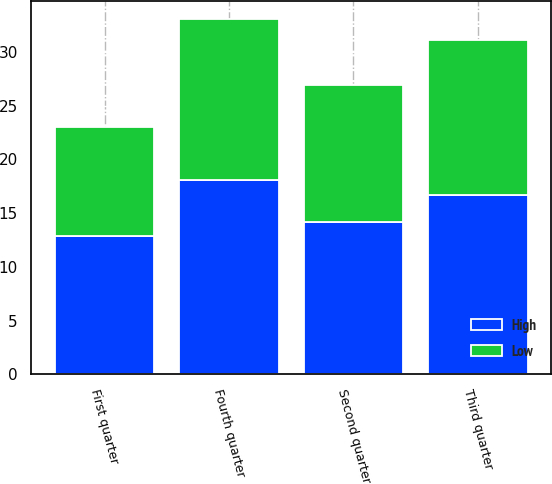Convert chart to OTSL. <chart><loc_0><loc_0><loc_500><loc_500><stacked_bar_chart><ecel><fcel>First quarter<fcel>Second quarter<fcel>Third quarter<fcel>Fourth quarter<nl><fcel>High<fcel>12.83<fcel>14.15<fcel>16.69<fcel>18.1<nl><fcel>Low<fcel>10.15<fcel>12.8<fcel>14.4<fcel>14.97<nl></chart> 